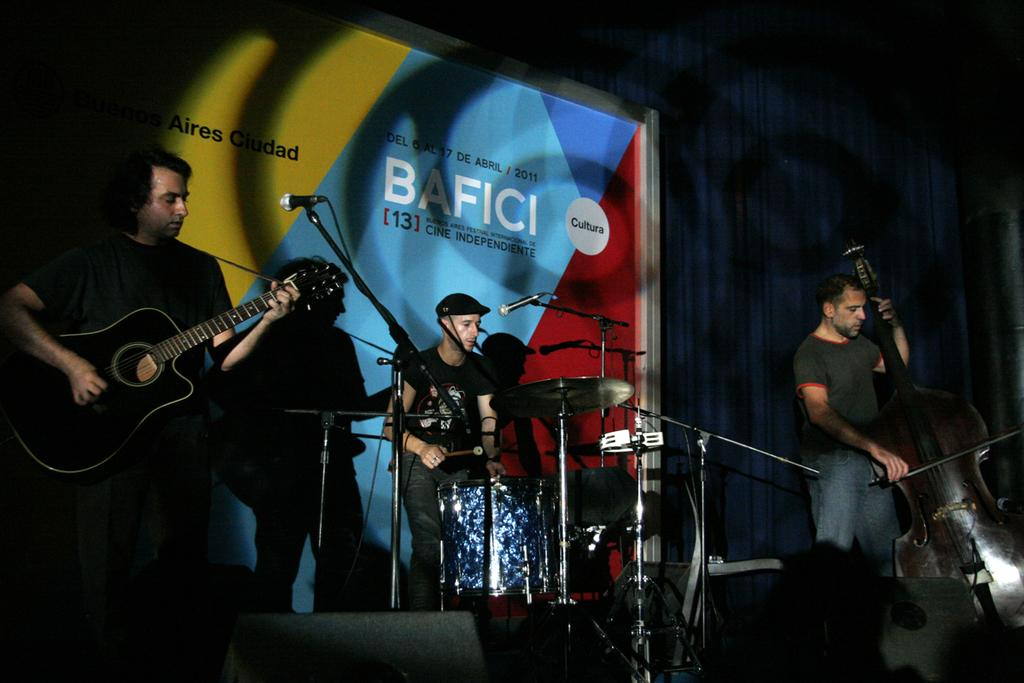How many people are in the image? There are three persons in the image. What are the persons doing in the image? The persons are performing on a stage. What instrument is one of the persons playing? One of the persons is playing a guitar. What are the other two persons doing on the stage? The other two persons are singing on a microphone. What type of poison is being used by the kittens in the library in the image? There are no kittens or poison present in the image, and it does not depict a library. 